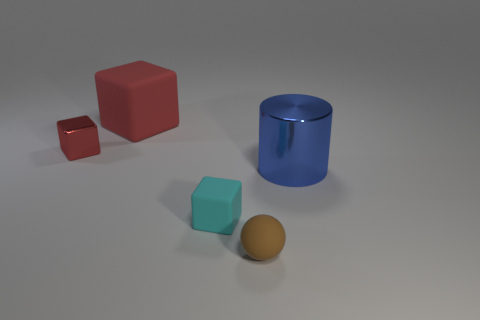There is a tiny cube that is the same color as the big rubber thing; what is it made of?
Provide a succinct answer. Metal. Is there a cyan thing that has the same size as the cyan block?
Make the answer very short. No. There is a matte block that is in front of the large blue cylinder; what is its size?
Ensure brevity in your answer.  Small. The blue metal object has what size?
Ensure brevity in your answer.  Large. What number of cylinders are either blue shiny objects or small brown rubber objects?
Offer a terse response. 1. What size is the cyan cube that is the same material as the ball?
Make the answer very short. Small. What number of tiny shiny blocks have the same color as the big rubber block?
Your answer should be very brief. 1. There is a brown rubber object; are there any tiny rubber things behind it?
Offer a very short reply. Yes. There is a big shiny object; does it have the same shape as the shiny object that is behind the large blue metal object?
Your response must be concise. No. How many objects are tiny things that are on the right side of the red matte cube or tiny metal things?
Your answer should be very brief. 3. 